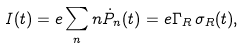<formula> <loc_0><loc_0><loc_500><loc_500>I ( t ) = e \sum _ { n } n \dot { P } _ { n } ( t ) = e \Gamma _ { R } \, \sigma _ { R } ( t ) ,</formula> 